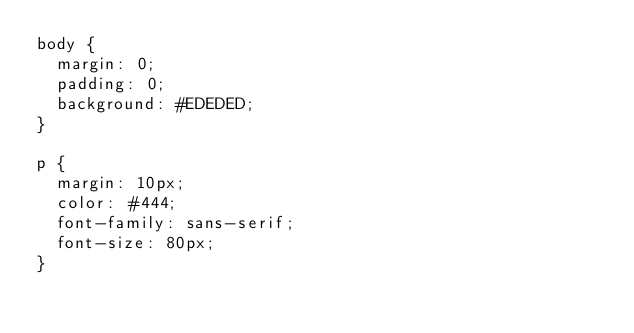Convert code to text. <code><loc_0><loc_0><loc_500><loc_500><_CSS_>body {
  margin: 0;
  padding: 0;
  background: #EDEDED;
}

p {
  margin: 10px;
  color: #444;
  font-family: sans-serif;
  font-size: 80px;
}
</code> 